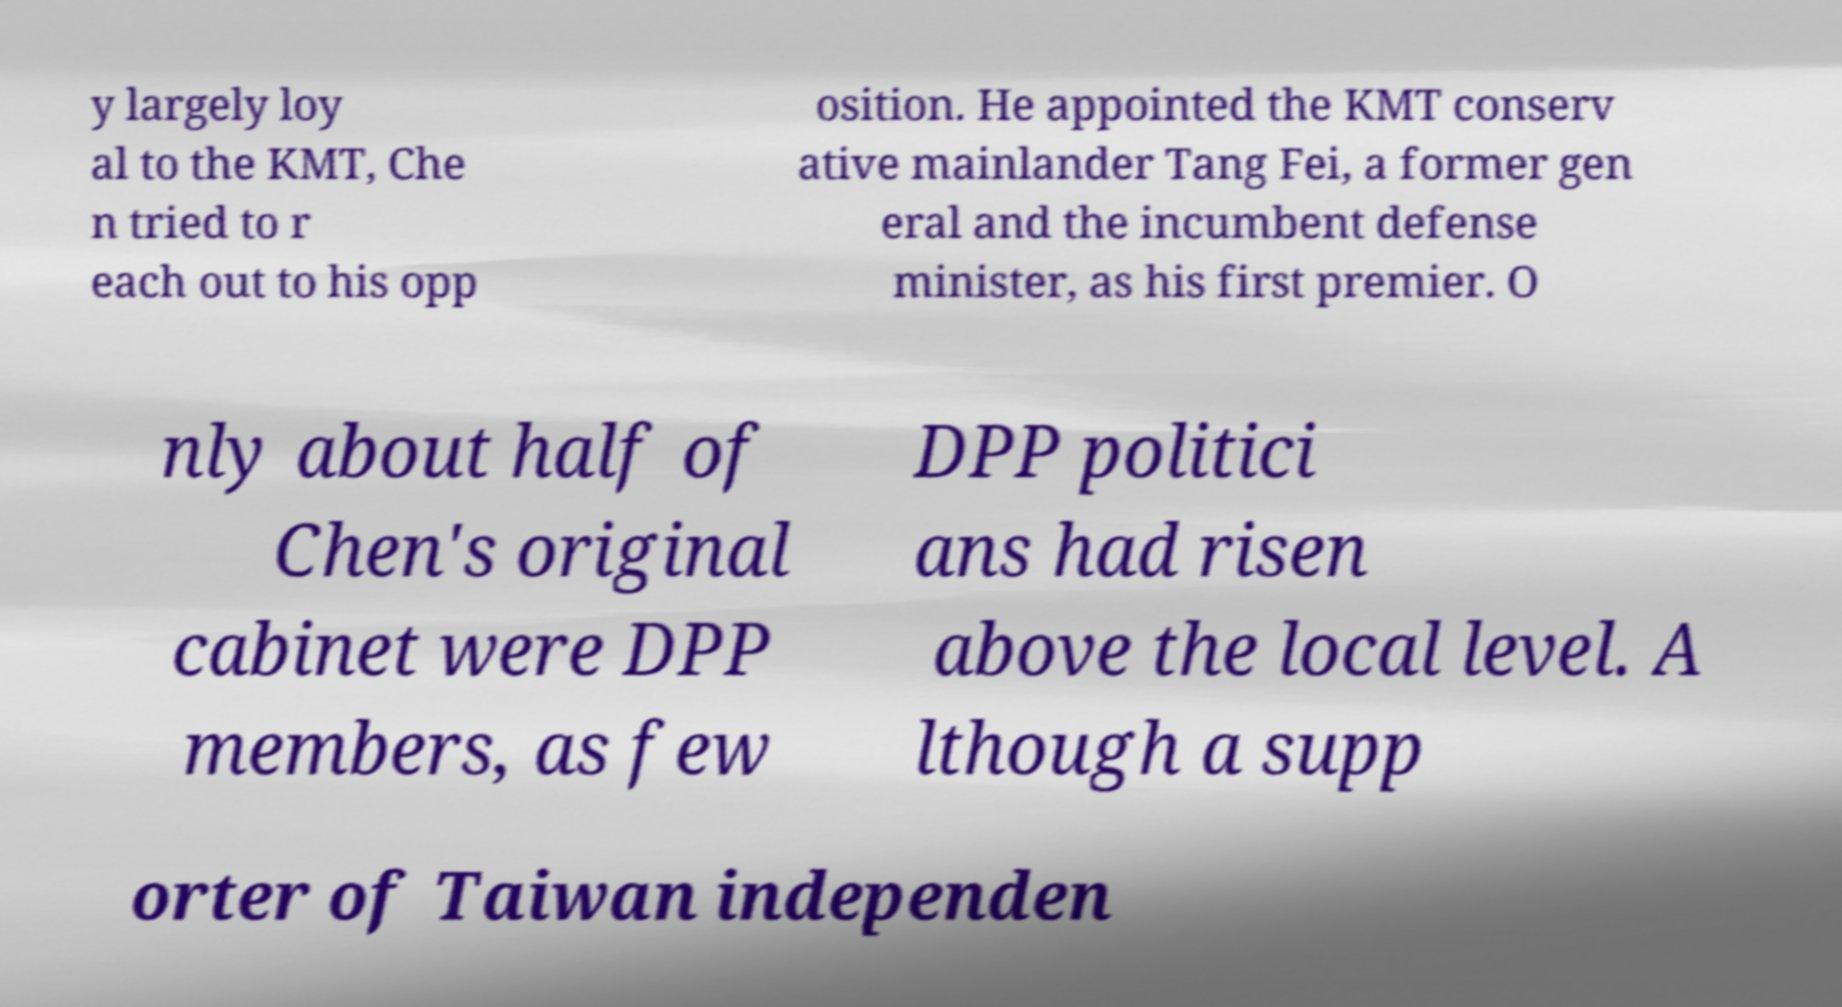Can you accurately transcribe the text from the provided image for me? y largely loy al to the KMT, Che n tried to r each out to his opp osition. He appointed the KMT conserv ative mainlander Tang Fei, a former gen eral and the incumbent defense minister, as his first premier. O nly about half of Chen's original cabinet were DPP members, as few DPP politici ans had risen above the local level. A lthough a supp orter of Taiwan independen 